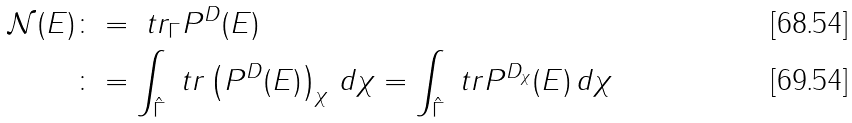Convert formula to latex. <formula><loc_0><loc_0><loc_500><loc_500>\mathcal { N } ( E ) & \colon = \ t r _ { \Gamma } P ^ { D } ( E ) \\ & \colon = \int _ { \hat { \Gamma } } \ t r \left ( P ^ { D } ( E ) \right ) _ { \chi } \, d \chi = \int _ { \hat { \Gamma } } \ t r P ^ { D _ { \chi } } ( E ) \, d \chi</formula> 